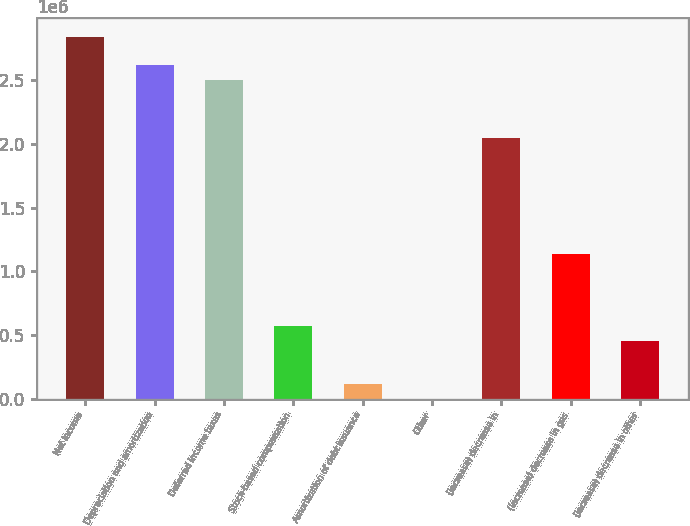Convert chart to OTSL. <chart><loc_0><loc_0><loc_500><loc_500><bar_chart><fcel>Net income<fcel>Depreciation and amortization<fcel>Deferred income taxes<fcel>Stock-based compensation<fcel>Amortization of debt issuance<fcel>Other<fcel>(Increase) decrease in<fcel>(Increase) decrease in gas<fcel>(Increase) decrease in other<nl><fcel>2.84258e+06<fcel>2.61518e+06<fcel>2.50148e+06<fcel>568593<fcel>113796<fcel>97<fcel>2.04668e+06<fcel>1.13709e+06<fcel>454894<nl></chart> 